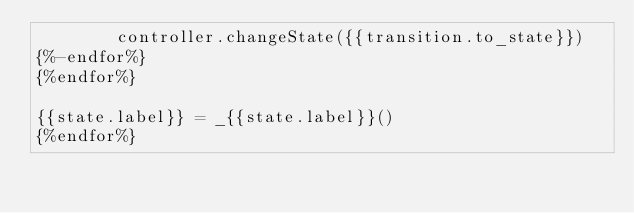Convert code to text. <code><loc_0><loc_0><loc_500><loc_500><_Python_>        controller.changeState({{transition.to_state}})
{%-endfor%}
{%endfor%}

{{state.label}} = _{{state.label}}()
{%endfor%}

</code> 